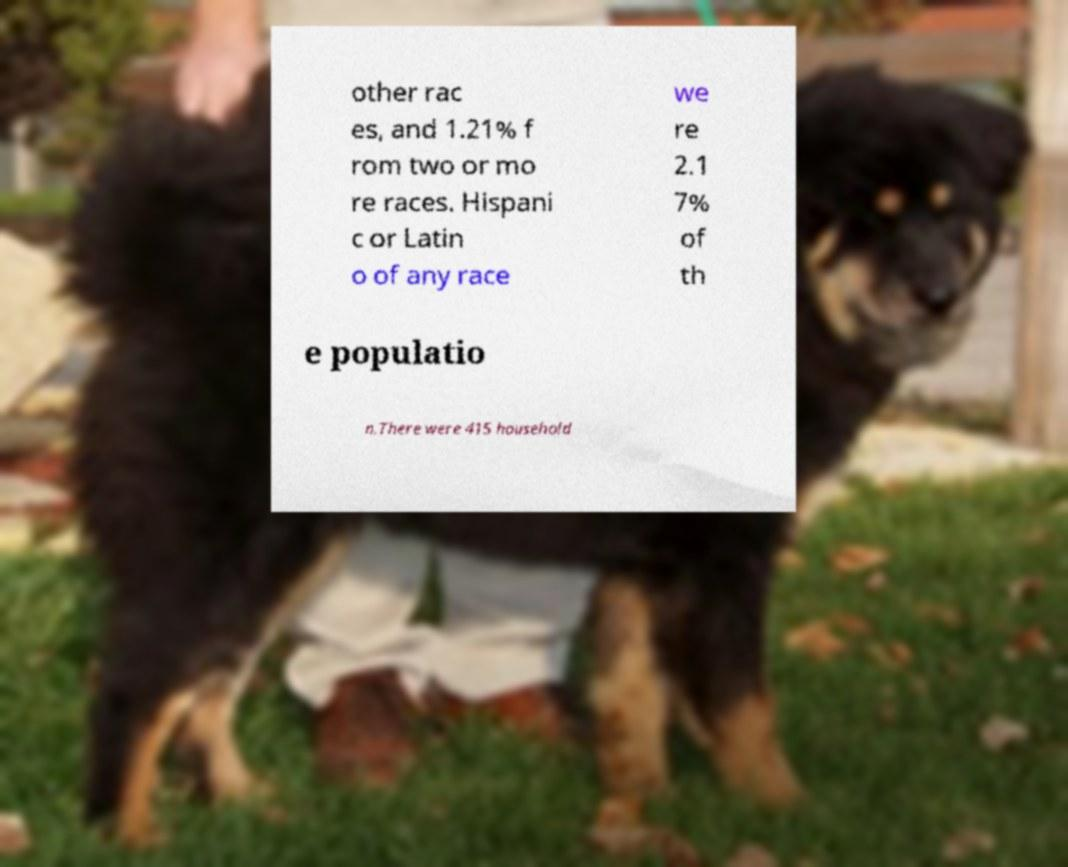Can you read and provide the text displayed in the image?This photo seems to have some interesting text. Can you extract and type it out for me? other rac es, and 1.21% f rom two or mo re races. Hispani c or Latin o of any race we re 2.1 7% of th e populatio n.There were 415 household 